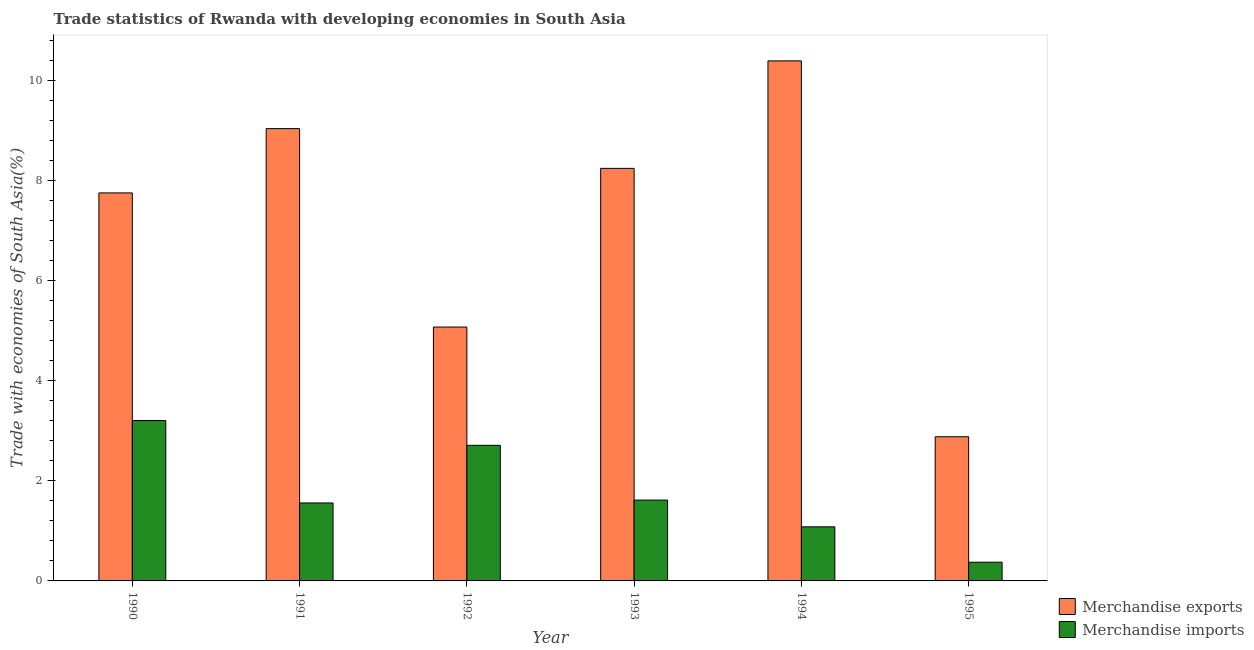How many different coloured bars are there?
Offer a terse response. 2. Are the number of bars per tick equal to the number of legend labels?
Offer a very short reply. Yes. How many bars are there on the 4th tick from the left?
Make the answer very short. 2. What is the label of the 3rd group of bars from the left?
Offer a very short reply. 1992. In how many cases, is the number of bars for a given year not equal to the number of legend labels?
Offer a very short reply. 0. What is the merchandise imports in 1993?
Your answer should be compact. 1.61. Across all years, what is the maximum merchandise exports?
Ensure brevity in your answer.  10.39. Across all years, what is the minimum merchandise imports?
Offer a terse response. 0.37. In which year was the merchandise imports maximum?
Offer a very short reply. 1990. In which year was the merchandise exports minimum?
Your response must be concise. 1995. What is the total merchandise imports in the graph?
Your answer should be compact. 10.54. What is the difference between the merchandise exports in 1991 and that in 1993?
Provide a short and direct response. 0.79. What is the difference between the merchandise imports in 1991 and the merchandise exports in 1993?
Offer a terse response. -0.06. What is the average merchandise imports per year?
Ensure brevity in your answer.  1.76. In the year 1994, what is the difference between the merchandise imports and merchandise exports?
Offer a very short reply. 0. In how many years, is the merchandise imports greater than 1.6 %?
Provide a short and direct response. 3. What is the ratio of the merchandise imports in 1991 to that in 1994?
Your answer should be compact. 1.44. Is the difference between the merchandise exports in 1994 and 1995 greater than the difference between the merchandise imports in 1994 and 1995?
Offer a terse response. No. What is the difference between the highest and the second highest merchandise exports?
Provide a succinct answer. 1.35. What is the difference between the highest and the lowest merchandise imports?
Your answer should be very brief. 2.83. Is the sum of the merchandise exports in 1991 and 1992 greater than the maximum merchandise imports across all years?
Provide a succinct answer. Yes. Are all the bars in the graph horizontal?
Provide a short and direct response. No. How many years are there in the graph?
Offer a terse response. 6. What is the difference between two consecutive major ticks on the Y-axis?
Keep it short and to the point. 2. Does the graph contain any zero values?
Give a very brief answer. No. Does the graph contain grids?
Make the answer very short. No. Where does the legend appear in the graph?
Your answer should be very brief. Bottom right. How are the legend labels stacked?
Make the answer very short. Vertical. What is the title of the graph?
Keep it short and to the point. Trade statistics of Rwanda with developing economies in South Asia. What is the label or title of the Y-axis?
Give a very brief answer. Trade with economies of South Asia(%). What is the Trade with economies of South Asia(%) in Merchandise exports in 1990?
Your answer should be compact. 7.75. What is the Trade with economies of South Asia(%) in Merchandise imports in 1990?
Your answer should be very brief. 3.2. What is the Trade with economies of South Asia(%) of Merchandise exports in 1991?
Your response must be concise. 9.04. What is the Trade with economies of South Asia(%) of Merchandise imports in 1991?
Make the answer very short. 1.56. What is the Trade with economies of South Asia(%) in Merchandise exports in 1992?
Give a very brief answer. 5.07. What is the Trade with economies of South Asia(%) in Merchandise imports in 1992?
Provide a succinct answer. 2.71. What is the Trade with economies of South Asia(%) of Merchandise exports in 1993?
Your answer should be very brief. 8.24. What is the Trade with economies of South Asia(%) in Merchandise imports in 1993?
Your answer should be compact. 1.61. What is the Trade with economies of South Asia(%) in Merchandise exports in 1994?
Give a very brief answer. 10.39. What is the Trade with economies of South Asia(%) of Merchandise imports in 1994?
Provide a succinct answer. 1.08. What is the Trade with economies of South Asia(%) in Merchandise exports in 1995?
Offer a terse response. 2.88. What is the Trade with economies of South Asia(%) of Merchandise imports in 1995?
Your answer should be very brief. 0.37. Across all years, what is the maximum Trade with economies of South Asia(%) in Merchandise exports?
Your response must be concise. 10.39. Across all years, what is the maximum Trade with economies of South Asia(%) of Merchandise imports?
Ensure brevity in your answer.  3.2. Across all years, what is the minimum Trade with economies of South Asia(%) of Merchandise exports?
Your answer should be compact. 2.88. Across all years, what is the minimum Trade with economies of South Asia(%) in Merchandise imports?
Make the answer very short. 0.37. What is the total Trade with economies of South Asia(%) in Merchandise exports in the graph?
Keep it short and to the point. 43.37. What is the total Trade with economies of South Asia(%) in Merchandise imports in the graph?
Provide a succinct answer. 10.54. What is the difference between the Trade with economies of South Asia(%) in Merchandise exports in 1990 and that in 1991?
Your answer should be very brief. -1.28. What is the difference between the Trade with economies of South Asia(%) of Merchandise imports in 1990 and that in 1991?
Offer a terse response. 1.65. What is the difference between the Trade with economies of South Asia(%) of Merchandise exports in 1990 and that in 1992?
Your response must be concise. 2.68. What is the difference between the Trade with economies of South Asia(%) in Merchandise imports in 1990 and that in 1992?
Provide a succinct answer. 0.5. What is the difference between the Trade with economies of South Asia(%) of Merchandise exports in 1990 and that in 1993?
Keep it short and to the point. -0.49. What is the difference between the Trade with economies of South Asia(%) of Merchandise imports in 1990 and that in 1993?
Your response must be concise. 1.59. What is the difference between the Trade with economies of South Asia(%) in Merchandise exports in 1990 and that in 1994?
Give a very brief answer. -2.64. What is the difference between the Trade with economies of South Asia(%) in Merchandise imports in 1990 and that in 1994?
Your response must be concise. 2.12. What is the difference between the Trade with economies of South Asia(%) of Merchandise exports in 1990 and that in 1995?
Offer a terse response. 4.87. What is the difference between the Trade with economies of South Asia(%) of Merchandise imports in 1990 and that in 1995?
Keep it short and to the point. 2.83. What is the difference between the Trade with economies of South Asia(%) of Merchandise exports in 1991 and that in 1992?
Your answer should be very brief. 3.96. What is the difference between the Trade with economies of South Asia(%) in Merchandise imports in 1991 and that in 1992?
Offer a terse response. -1.15. What is the difference between the Trade with economies of South Asia(%) in Merchandise exports in 1991 and that in 1993?
Give a very brief answer. 0.79. What is the difference between the Trade with economies of South Asia(%) in Merchandise imports in 1991 and that in 1993?
Give a very brief answer. -0.06. What is the difference between the Trade with economies of South Asia(%) of Merchandise exports in 1991 and that in 1994?
Offer a terse response. -1.35. What is the difference between the Trade with economies of South Asia(%) of Merchandise imports in 1991 and that in 1994?
Your response must be concise. 0.48. What is the difference between the Trade with economies of South Asia(%) in Merchandise exports in 1991 and that in 1995?
Your answer should be very brief. 6.16. What is the difference between the Trade with economies of South Asia(%) in Merchandise imports in 1991 and that in 1995?
Make the answer very short. 1.18. What is the difference between the Trade with economies of South Asia(%) of Merchandise exports in 1992 and that in 1993?
Provide a short and direct response. -3.17. What is the difference between the Trade with economies of South Asia(%) in Merchandise imports in 1992 and that in 1993?
Your response must be concise. 1.09. What is the difference between the Trade with economies of South Asia(%) of Merchandise exports in 1992 and that in 1994?
Ensure brevity in your answer.  -5.32. What is the difference between the Trade with economies of South Asia(%) in Merchandise imports in 1992 and that in 1994?
Provide a short and direct response. 1.63. What is the difference between the Trade with economies of South Asia(%) of Merchandise exports in 1992 and that in 1995?
Your answer should be compact. 2.19. What is the difference between the Trade with economies of South Asia(%) of Merchandise imports in 1992 and that in 1995?
Make the answer very short. 2.33. What is the difference between the Trade with economies of South Asia(%) of Merchandise exports in 1993 and that in 1994?
Provide a short and direct response. -2.15. What is the difference between the Trade with economies of South Asia(%) of Merchandise imports in 1993 and that in 1994?
Ensure brevity in your answer.  0.53. What is the difference between the Trade with economies of South Asia(%) of Merchandise exports in 1993 and that in 1995?
Provide a short and direct response. 5.36. What is the difference between the Trade with economies of South Asia(%) in Merchandise imports in 1993 and that in 1995?
Give a very brief answer. 1.24. What is the difference between the Trade with economies of South Asia(%) of Merchandise exports in 1994 and that in 1995?
Provide a short and direct response. 7.51. What is the difference between the Trade with economies of South Asia(%) in Merchandise imports in 1994 and that in 1995?
Provide a succinct answer. 0.71. What is the difference between the Trade with economies of South Asia(%) in Merchandise exports in 1990 and the Trade with economies of South Asia(%) in Merchandise imports in 1991?
Your answer should be very brief. 6.19. What is the difference between the Trade with economies of South Asia(%) of Merchandise exports in 1990 and the Trade with economies of South Asia(%) of Merchandise imports in 1992?
Offer a terse response. 5.04. What is the difference between the Trade with economies of South Asia(%) of Merchandise exports in 1990 and the Trade with economies of South Asia(%) of Merchandise imports in 1993?
Provide a short and direct response. 6.14. What is the difference between the Trade with economies of South Asia(%) in Merchandise exports in 1990 and the Trade with economies of South Asia(%) in Merchandise imports in 1994?
Your response must be concise. 6.67. What is the difference between the Trade with economies of South Asia(%) of Merchandise exports in 1990 and the Trade with economies of South Asia(%) of Merchandise imports in 1995?
Ensure brevity in your answer.  7.38. What is the difference between the Trade with economies of South Asia(%) of Merchandise exports in 1991 and the Trade with economies of South Asia(%) of Merchandise imports in 1992?
Your answer should be compact. 6.33. What is the difference between the Trade with economies of South Asia(%) in Merchandise exports in 1991 and the Trade with economies of South Asia(%) in Merchandise imports in 1993?
Offer a very short reply. 7.42. What is the difference between the Trade with economies of South Asia(%) in Merchandise exports in 1991 and the Trade with economies of South Asia(%) in Merchandise imports in 1994?
Your answer should be very brief. 7.95. What is the difference between the Trade with economies of South Asia(%) of Merchandise exports in 1991 and the Trade with economies of South Asia(%) of Merchandise imports in 1995?
Ensure brevity in your answer.  8.66. What is the difference between the Trade with economies of South Asia(%) in Merchandise exports in 1992 and the Trade with economies of South Asia(%) in Merchandise imports in 1993?
Offer a terse response. 3.46. What is the difference between the Trade with economies of South Asia(%) in Merchandise exports in 1992 and the Trade with economies of South Asia(%) in Merchandise imports in 1994?
Your answer should be very brief. 3.99. What is the difference between the Trade with economies of South Asia(%) in Merchandise exports in 1992 and the Trade with economies of South Asia(%) in Merchandise imports in 1995?
Your answer should be compact. 4.7. What is the difference between the Trade with economies of South Asia(%) of Merchandise exports in 1993 and the Trade with economies of South Asia(%) of Merchandise imports in 1994?
Ensure brevity in your answer.  7.16. What is the difference between the Trade with economies of South Asia(%) of Merchandise exports in 1993 and the Trade with economies of South Asia(%) of Merchandise imports in 1995?
Provide a short and direct response. 7.87. What is the difference between the Trade with economies of South Asia(%) of Merchandise exports in 1994 and the Trade with economies of South Asia(%) of Merchandise imports in 1995?
Ensure brevity in your answer.  10.01. What is the average Trade with economies of South Asia(%) in Merchandise exports per year?
Provide a succinct answer. 7.23. What is the average Trade with economies of South Asia(%) of Merchandise imports per year?
Your answer should be compact. 1.76. In the year 1990, what is the difference between the Trade with economies of South Asia(%) in Merchandise exports and Trade with economies of South Asia(%) in Merchandise imports?
Give a very brief answer. 4.55. In the year 1991, what is the difference between the Trade with economies of South Asia(%) of Merchandise exports and Trade with economies of South Asia(%) of Merchandise imports?
Make the answer very short. 7.48. In the year 1992, what is the difference between the Trade with economies of South Asia(%) of Merchandise exports and Trade with economies of South Asia(%) of Merchandise imports?
Offer a terse response. 2.36. In the year 1993, what is the difference between the Trade with economies of South Asia(%) in Merchandise exports and Trade with economies of South Asia(%) in Merchandise imports?
Offer a very short reply. 6.63. In the year 1994, what is the difference between the Trade with economies of South Asia(%) of Merchandise exports and Trade with economies of South Asia(%) of Merchandise imports?
Give a very brief answer. 9.31. In the year 1995, what is the difference between the Trade with economies of South Asia(%) in Merchandise exports and Trade with economies of South Asia(%) in Merchandise imports?
Provide a short and direct response. 2.51. What is the ratio of the Trade with economies of South Asia(%) in Merchandise exports in 1990 to that in 1991?
Your answer should be compact. 0.86. What is the ratio of the Trade with economies of South Asia(%) in Merchandise imports in 1990 to that in 1991?
Make the answer very short. 2.06. What is the ratio of the Trade with economies of South Asia(%) of Merchandise exports in 1990 to that in 1992?
Your answer should be compact. 1.53. What is the ratio of the Trade with economies of South Asia(%) in Merchandise imports in 1990 to that in 1992?
Your answer should be compact. 1.18. What is the ratio of the Trade with economies of South Asia(%) of Merchandise exports in 1990 to that in 1993?
Keep it short and to the point. 0.94. What is the ratio of the Trade with economies of South Asia(%) of Merchandise imports in 1990 to that in 1993?
Your answer should be very brief. 1.98. What is the ratio of the Trade with economies of South Asia(%) of Merchandise exports in 1990 to that in 1994?
Your answer should be compact. 0.75. What is the ratio of the Trade with economies of South Asia(%) in Merchandise imports in 1990 to that in 1994?
Offer a terse response. 2.97. What is the ratio of the Trade with economies of South Asia(%) in Merchandise exports in 1990 to that in 1995?
Provide a short and direct response. 2.69. What is the ratio of the Trade with economies of South Asia(%) in Merchandise imports in 1990 to that in 1995?
Keep it short and to the point. 8.57. What is the ratio of the Trade with economies of South Asia(%) of Merchandise exports in 1991 to that in 1992?
Give a very brief answer. 1.78. What is the ratio of the Trade with economies of South Asia(%) in Merchandise imports in 1991 to that in 1992?
Offer a very short reply. 0.57. What is the ratio of the Trade with economies of South Asia(%) in Merchandise exports in 1991 to that in 1993?
Provide a succinct answer. 1.1. What is the ratio of the Trade with economies of South Asia(%) of Merchandise imports in 1991 to that in 1993?
Make the answer very short. 0.96. What is the ratio of the Trade with economies of South Asia(%) of Merchandise exports in 1991 to that in 1994?
Offer a terse response. 0.87. What is the ratio of the Trade with economies of South Asia(%) of Merchandise imports in 1991 to that in 1994?
Make the answer very short. 1.44. What is the ratio of the Trade with economies of South Asia(%) in Merchandise exports in 1991 to that in 1995?
Provide a short and direct response. 3.14. What is the ratio of the Trade with economies of South Asia(%) in Merchandise imports in 1991 to that in 1995?
Give a very brief answer. 4.17. What is the ratio of the Trade with economies of South Asia(%) in Merchandise exports in 1992 to that in 1993?
Your answer should be compact. 0.62. What is the ratio of the Trade with economies of South Asia(%) in Merchandise imports in 1992 to that in 1993?
Give a very brief answer. 1.68. What is the ratio of the Trade with economies of South Asia(%) of Merchandise exports in 1992 to that in 1994?
Your answer should be very brief. 0.49. What is the ratio of the Trade with economies of South Asia(%) in Merchandise imports in 1992 to that in 1994?
Your answer should be compact. 2.51. What is the ratio of the Trade with economies of South Asia(%) of Merchandise exports in 1992 to that in 1995?
Offer a terse response. 1.76. What is the ratio of the Trade with economies of South Asia(%) of Merchandise imports in 1992 to that in 1995?
Your answer should be very brief. 7.25. What is the ratio of the Trade with economies of South Asia(%) in Merchandise exports in 1993 to that in 1994?
Your answer should be very brief. 0.79. What is the ratio of the Trade with economies of South Asia(%) in Merchandise imports in 1993 to that in 1994?
Your answer should be compact. 1.49. What is the ratio of the Trade with economies of South Asia(%) of Merchandise exports in 1993 to that in 1995?
Offer a very short reply. 2.86. What is the ratio of the Trade with economies of South Asia(%) of Merchandise imports in 1993 to that in 1995?
Your answer should be compact. 4.32. What is the ratio of the Trade with economies of South Asia(%) in Merchandise exports in 1994 to that in 1995?
Keep it short and to the point. 3.61. What is the ratio of the Trade with economies of South Asia(%) in Merchandise imports in 1994 to that in 1995?
Keep it short and to the point. 2.89. What is the difference between the highest and the second highest Trade with economies of South Asia(%) of Merchandise exports?
Ensure brevity in your answer.  1.35. What is the difference between the highest and the second highest Trade with economies of South Asia(%) of Merchandise imports?
Give a very brief answer. 0.5. What is the difference between the highest and the lowest Trade with economies of South Asia(%) of Merchandise exports?
Provide a succinct answer. 7.51. What is the difference between the highest and the lowest Trade with economies of South Asia(%) of Merchandise imports?
Ensure brevity in your answer.  2.83. 